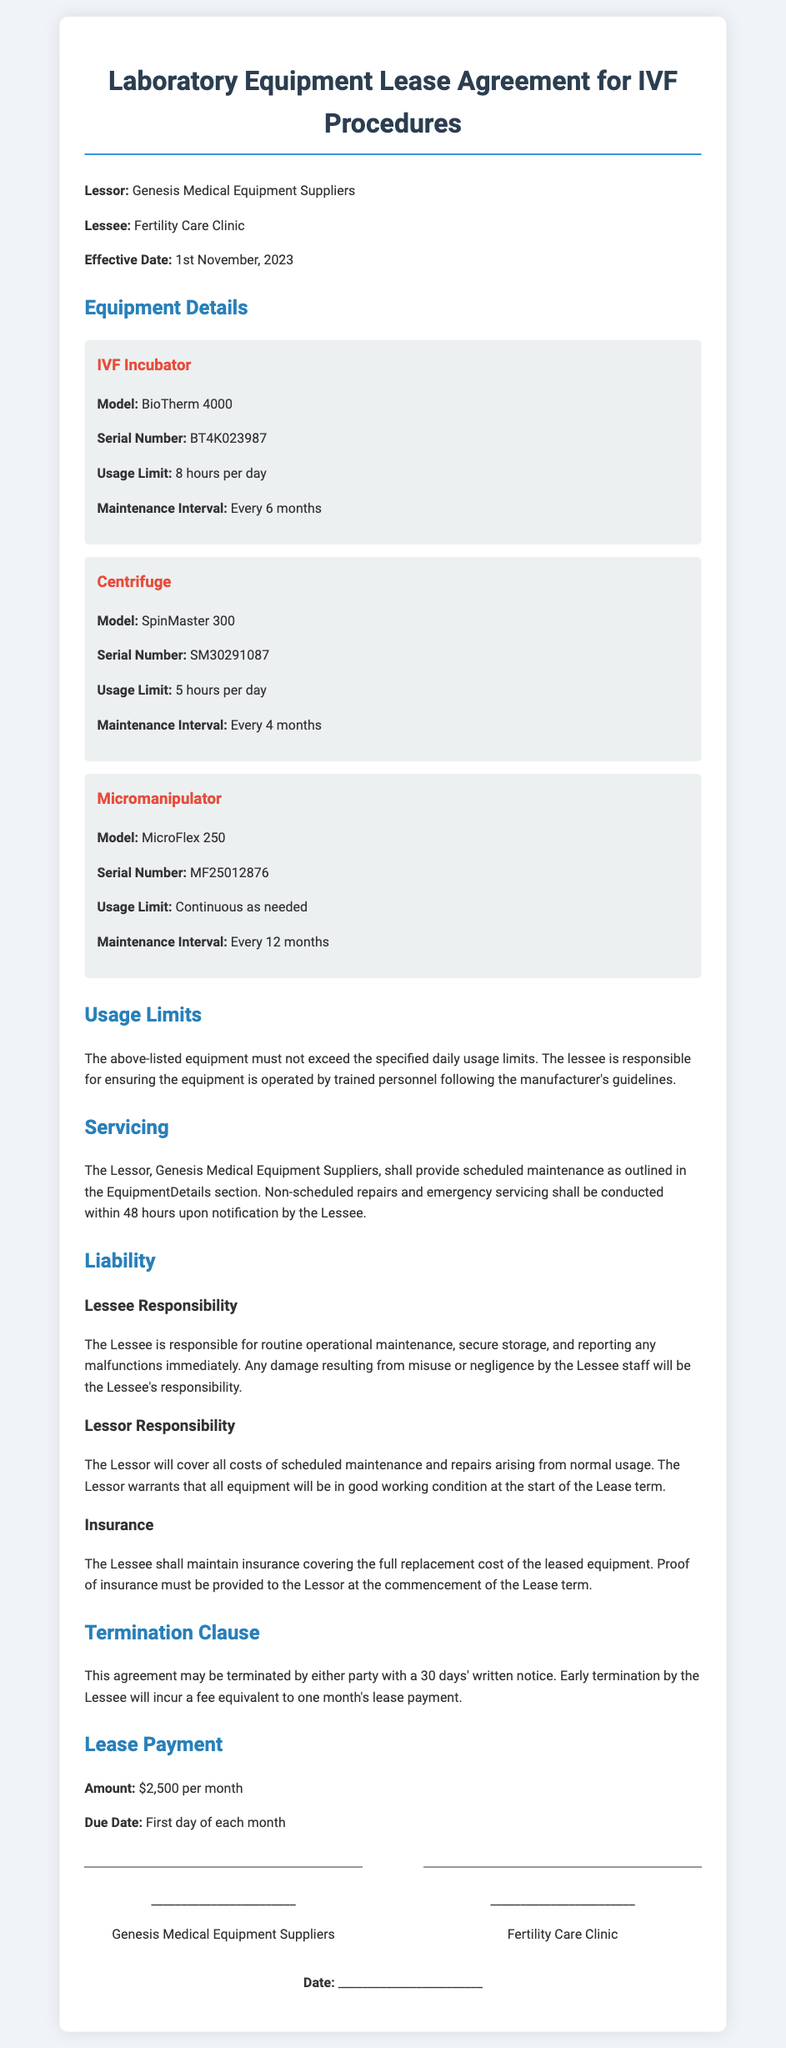What is the name of the lessor? The lessor is the entity that provides the leased equipment, which is Genesis Medical Equipment Suppliers.
Answer: Genesis Medical Equipment Suppliers What is the monthly lease payment amount? The lease payment amount for the equipment is stated in the document as $2,500 per month.
Answer: $2,500 What is the effective date of the lease agreement? The effective date is provided in the document, marking when the lease begins, which is 1st November, 2023.
Answer: 1st November, 2023 What are the usage limits for the IVF incubator? The usage limit for the IVF incubator must not exceed the specified amount, which is 8 hours per day.
Answer: 8 hours per day What is the maintenance interval for the centrifuge? The document specifies the scheduled maintenance interval for the centrifuge is every 4 months.
Answer: Every 4 months Is the lessee responsible for damage due to misuse? The document states that any damage resulting from misuse or negligence by the Lessee staff is the responsibility of the Lessee.
Answer: Yes What is the consequence of early termination by the lessee? The agreement includes a penalty for early termination, specifically a fee equivalent to one month's lease payment.
Answer: One month's lease payment How often must the lessee maintain insurance? The document requires the Lessee to maintain insurance covering the full replacement cost of the leased equipment without specifying a time interval, but it must be maintained at all times during the lease term.
Answer: At all times Who is responsible for emergency servicing? The lessor is responsible for conducting non-scheduled repairs and emergency servicing within 48 hours upon notification.
Answer: Lessor 